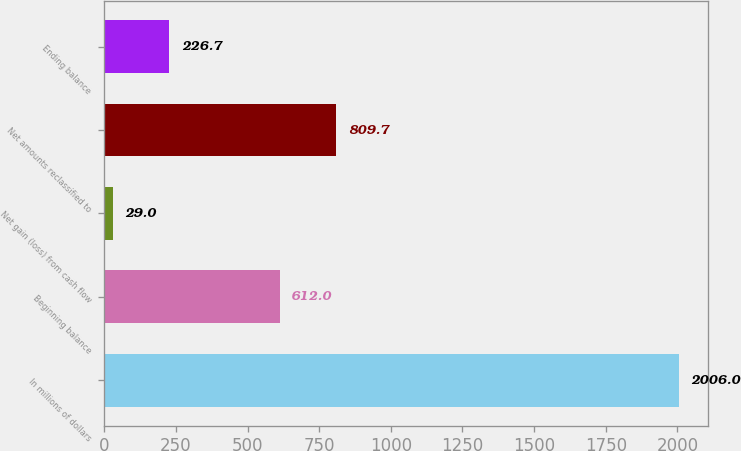Convert chart. <chart><loc_0><loc_0><loc_500><loc_500><bar_chart><fcel>In millions of dollars<fcel>Beginning balance<fcel>Net gain (loss) from cash flow<fcel>Net amounts reclassified to<fcel>Ending balance<nl><fcel>2006<fcel>612<fcel>29<fcel>809.7<fcel>226.7<nl></chart> 